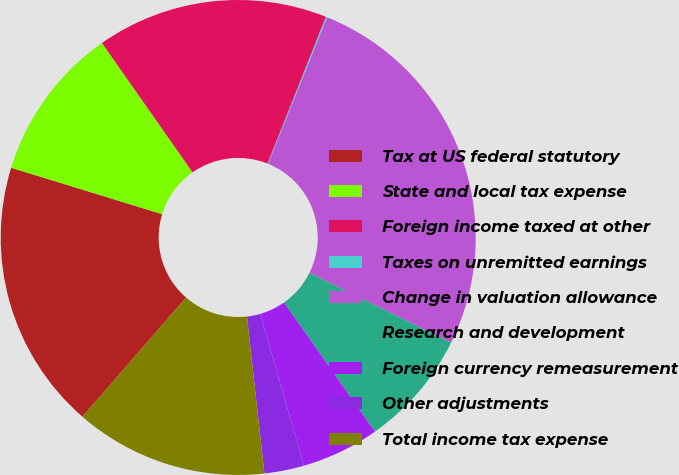Convert chart. <chart><loc_0><loc_0><loc_500><loc_500><pie_chart><fcel>Tax at US federal statutory<fcel>State and local tax expense<fcel>Foreign income taxed at other<fcel>Taxes on unremitted earnings<fcel>Change in valuation allowance<fcel>Research and development<fcel>Foreign currency remeasurement<fcel>Other adjustments<fcel>Total income tax expense<nl><fcel>18.36%<fcel>10.53%<fcel>15.75%<fcel>0.09%<fcel>26.19%<fcel>7.92%<fcel>5.31%<fcel>2.7%<fcel>13.14%<nl></chart> 